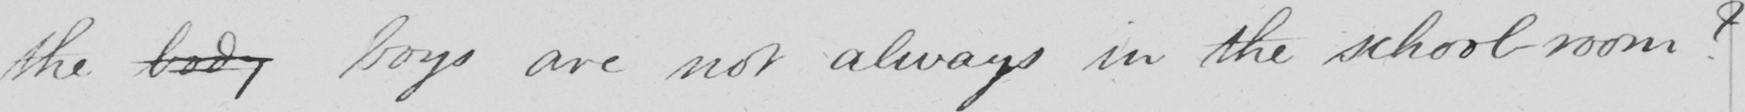What does this handwritten line say? the body boys are not always in the school room ? 